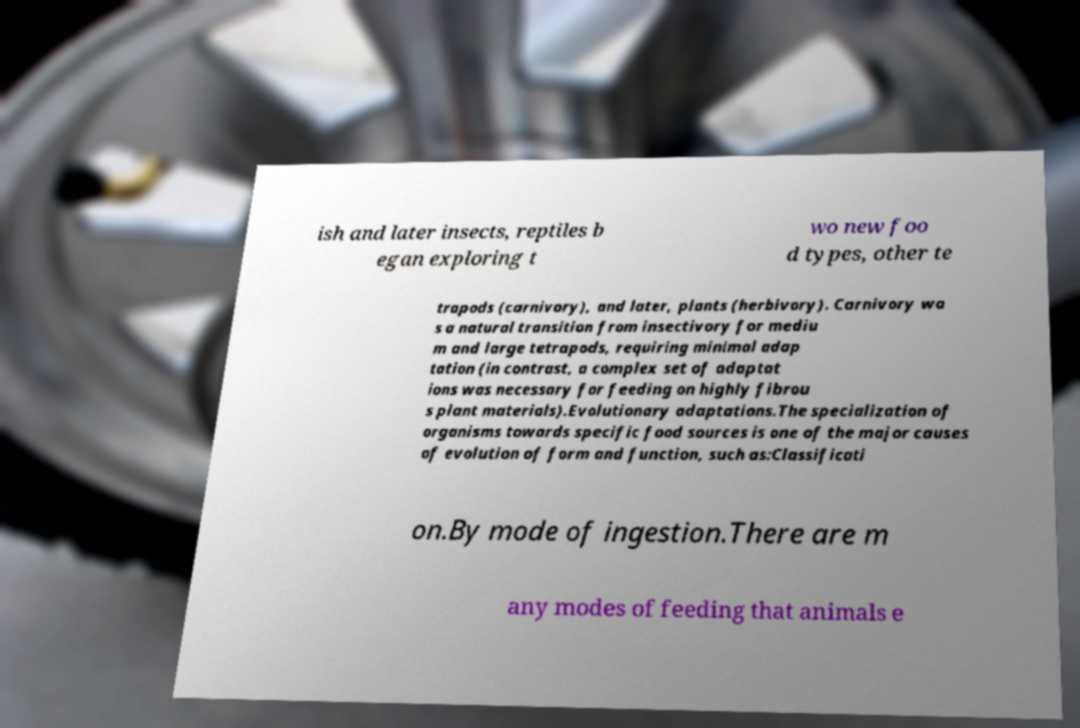What messages or text are displayed in this image? I need them in a readable, typed format. ish and later insects, reptiles b egan exploring t wo new foo d types, other te trapods (carnivory), and later, plants (herbivory). Carnivory wa s a natural transition from insectivory for mediu m and large tetrapods, requiring minimal adap tation (in contrast, a complex set of adaptat ions was necessary for feeding on highly fibrou s plant materials).Evolutionary adaptations.The specialization of organisms towards specific food sources is one of the major causes of evolution of form and function, such as:Classificati on.By mode of ingestion.There are m any modes of feeding that animals e 